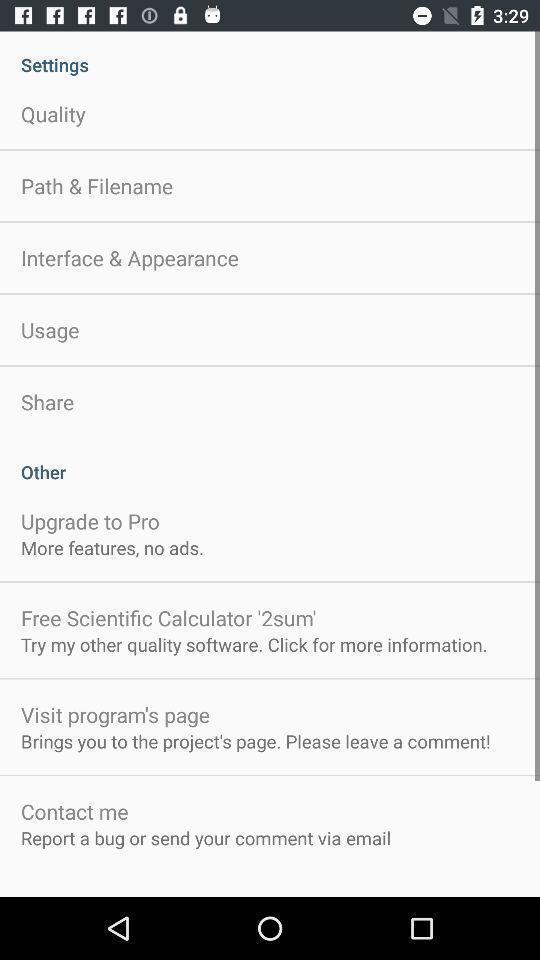What details can you identify in this image? Settings page on an app. 